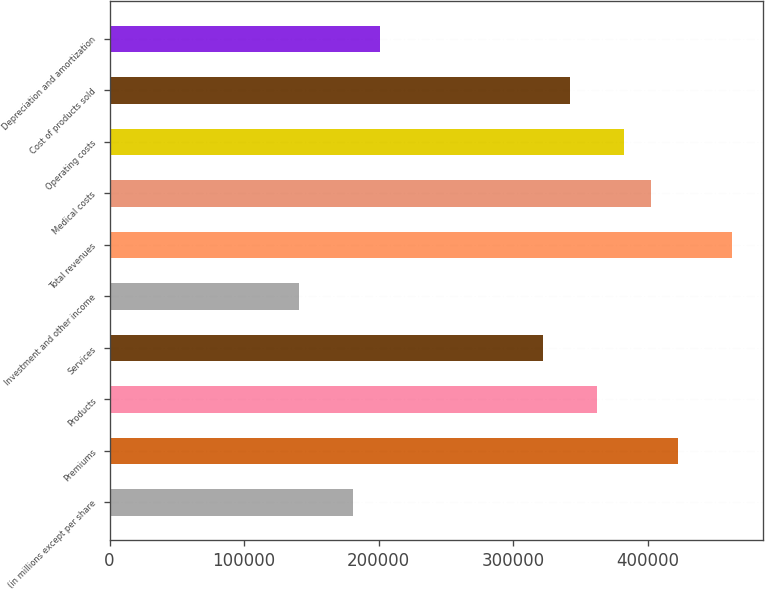Convert chart. <chart><loc_0><loc_0><loc_500><loc_500><bar_chart><fcel>(in millions except per share<fcel>Premiums<fcel>Products<fcel>Services<fcel>Investment and other income<fcel>Total revenues<fcel>Medical costs<fcel>Operating costs<fcel>Cost of products sold<fcel>Depreciation and amortization<nl><fcel>181044<fcel>422428<fcel>362082<fcel>321851<fcel>140813<fcel>462659<fcel>402313<fcel>382198<fcel>341967<fcel>201159<nl></chart> 